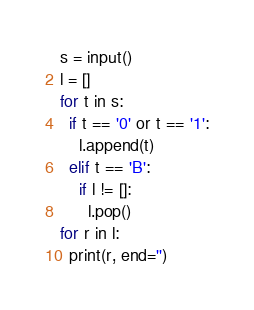<code> <loc_0><loc_0><loc_500><loc_500><_Python_>s = input()
l = []
for t in s:
  if t == '0' or t == '1':
    l.append(t)
  elif t == 'B':
    if l != []:
      l.pop()
for r in l:
  print(r, end='')
</code> 